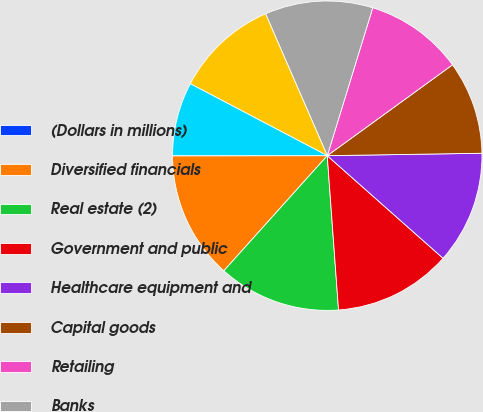Convert chart. <chart><loc_0><loc_0><loc_500><loc_500><pie_chart><fcel>(Dollars in millions)<fcel>Diversified financials<fcel>Real estate (2)<fcel>Government and public<fcel>Healthcare equipment and<fcel>Capital goods<fcel>Retailing<fcel>Banks<fcel>Consumer services<fcel>Materials<nl><fcel>0.02%<fcel>13.33%<fcel>12.81%<fcel>12.3%<fcel>11.79%<fcel>9.74%<fcel>10.26%<fcel>11.28%<fcel>10.77%<fcel>7.7%<nl></chart> 